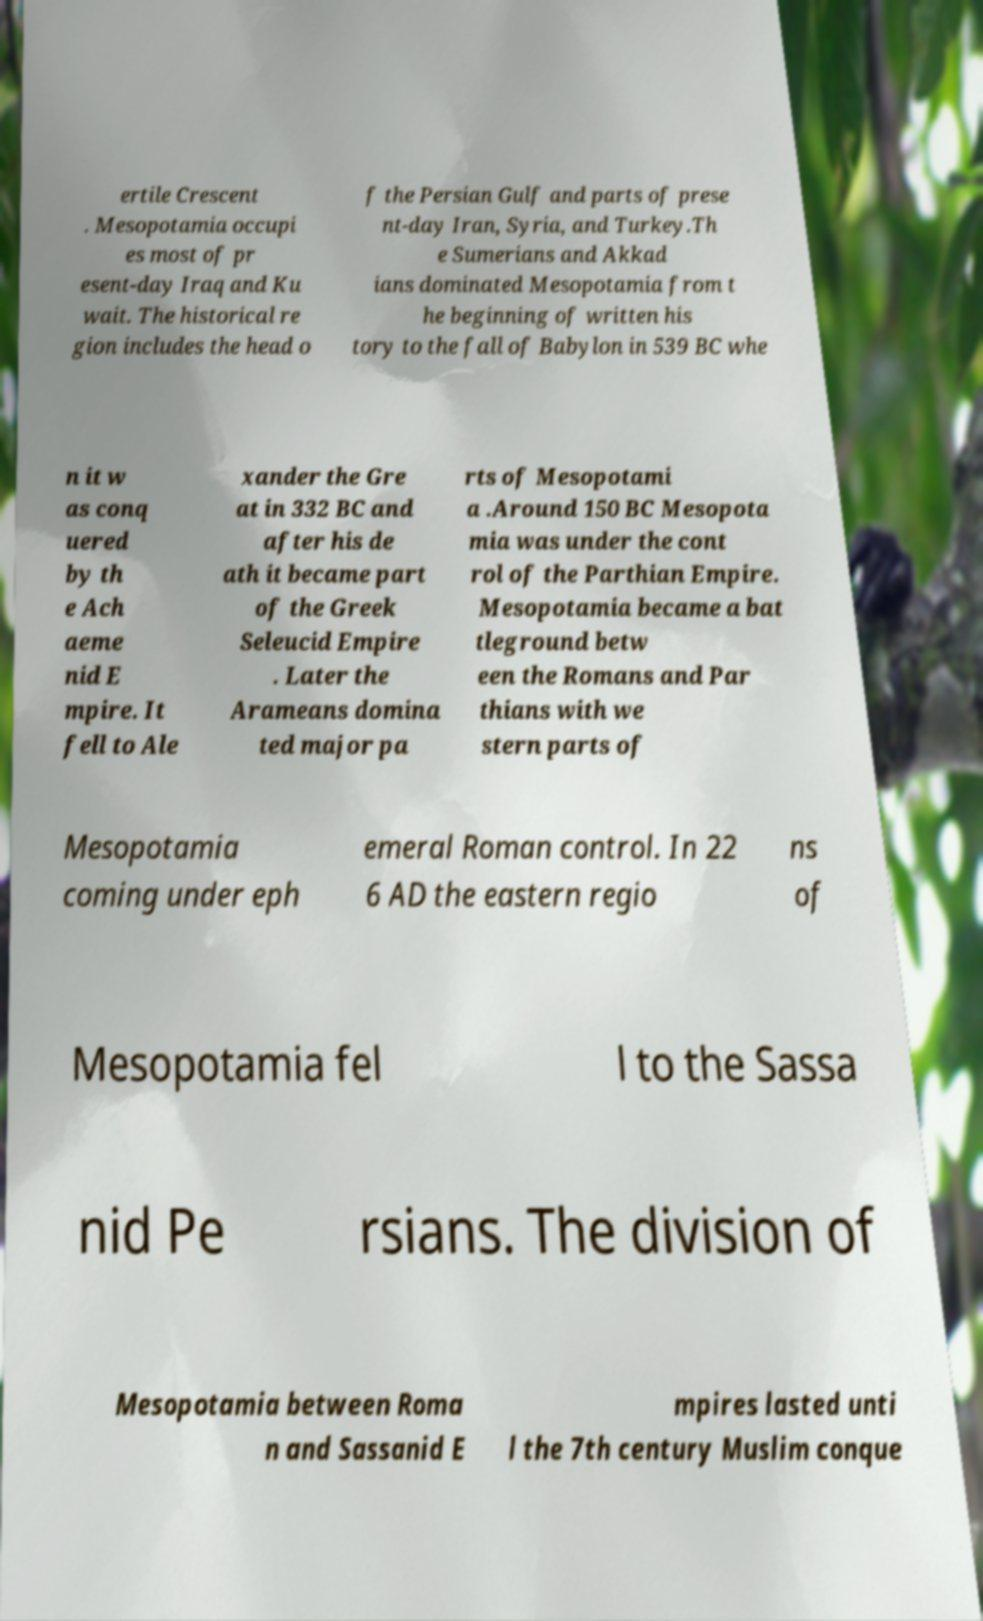Can you accurately transcribe the text from the provided image for me? ertile Crescent . Mesopotamia occupi es most of pr esent-day Iraq and Ku wait. The historical re gion includes the head o f the Persian Gulf and parts of prese nt-day Iran, Syria, and Turkey.Th e Sumerians and Akkad ians dominated Mesopotamia from t he beginning of written his tory to the fall of Babylon in 539 BC whe n it w as conq uered by th e Ach aeme nid E mpire. It fell to Ale xander the Gre at in 332 BC and after his de ath it became part of the Greek Seleucid Empire . Later the Arameans domina ted major pa rts of Mesopotami a .Around 150 BC Mesopota mia was under the cont rol of the Parthian Empire. Mesopotamia became a bat tleground betw een the Romans and Par thians with we stern parts of Mesopotamia coming under eph emeral Roman control. In 22 6 AD the eastern regio ns of Mesopotamia fel l to the Sassa nid Pe rsians. The division of Mesopotamia between Roma n and Sassanid E mpires lasted unti l the 7th century Muslim conque 